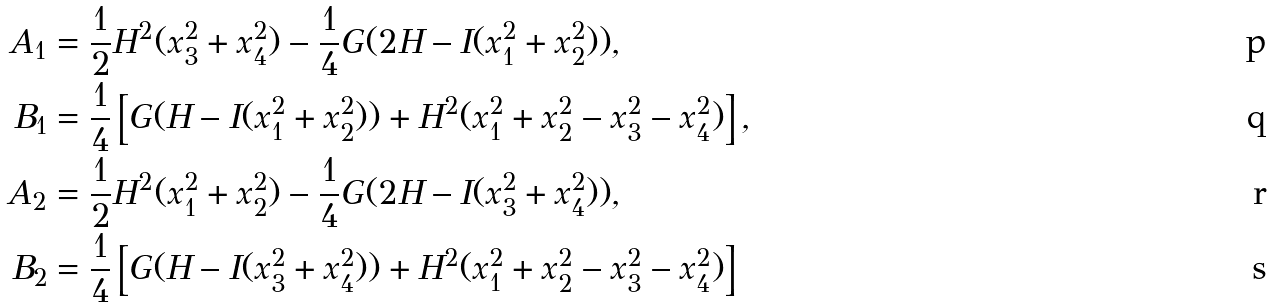Convert formula to latex. <formula><loc_0><loc_0><loc_500><loc_500>A _ { 1 } & = \frac { 1 } { 2 } H ^ { 2 } ( x _ { 3 } ^ { 2 } + x _ { 4 } ^ { 2 } ) - \frac { 1 } { 4 } G ( 2 H - I ( x _ { 1 } ^ { 2 } + x _ { 2 } ^ { 2 } ) ) , \\ B _ { 1 } & = \frac { 1 } { 4 } \left [ G ( H - I ( x _ { 1 } ^ { 2 } + x _ { 2 } ^ { 2 } ) ) + H ^ { 2 } ( x _ { 1 } ^ { 2 } + x _ { 2 } ^ { 2 } - x _ { 3 } ^ { 2 } - x _ { 4 } ^ { 2 } ) \right ] , \\ A _ { 2 } & = \frac { 1 } { 2 } H ^ { 2 } ( x _ { 1 } ^ { 2 } + x _ { 2 } ^ { 2 } ) - \frac { 1 } { 4 } G ( 2 H - I ( x _ { 3 } ^ { 2 } + x _ { 4 } ^ { 2 } ) ) , \\ B _ { 2 } & = \frac { 1 } { 4 } \left [ G ( H - I ( x _ { 3 } ^ { 2 } + x _ { 4 } ^ { 2 } ) ) + H ^ { 2 } ( x _ { 1 } ^ { 2 } + x _ { 2 } ^ { 2 } - x _ { 3 } ^ { 2 } - x _ { 4 } ^ { 2 } ) \right ]</formula> 